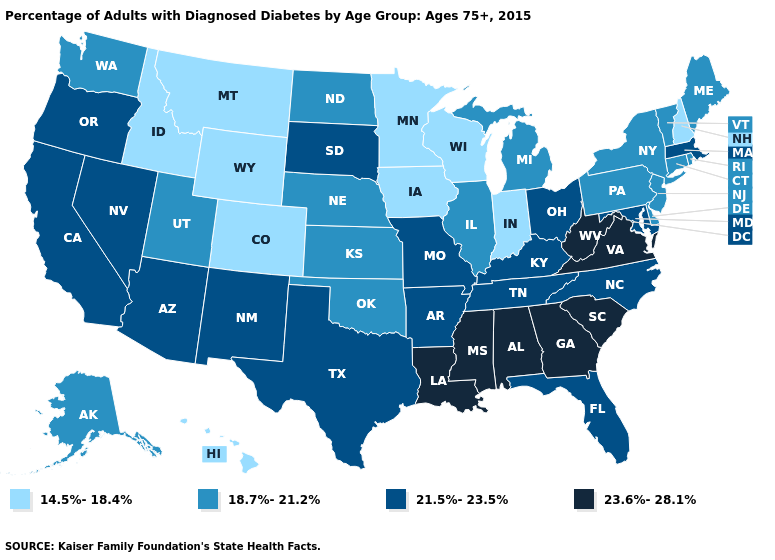Among the states that border North Dakota , which have the highest value?
Concise answer only. South Dakota. Is the legend a continuous bar?
Keep it brief. No. Does South Carolina have the lowest value in the USA?
Short answer required. No. Does Delaware have the same value as Indiana?
Be succinct. No. Among the states that border Delaware , does Maryland have the lowest value?
Keep it brief. No. What is the value of North Dakota?
Give a very brief answer. 18.7%-21.2%. What is the value of Massachusetts?
Concise answer only. 21.5%-23.5%. Among the states that border Rhode Island , does Connecticut have the lowest value?
Be succinct. Yes. Does Mississippi have a higher value than California?
Be succinct. Yes. How many symbols are there in the legend?
Short answer required. 4. Does Wyoming have the same value as New Mexico?
Keep it brief. No. Which states hav the highest value in the West?
Quick response, please. Arizona, California, Nevada, New Mexico, Oregon. Name the states that have a value in the range 18.7%-21.2%?
Write a very short answer. Alaska, Connecticut, Delaware, Illinois, Kansas, Maine, Michigan, Nebraska, New Jersey, New York, North Dakota, Oklahoma, Pennsylvania, Rhode Island, Utah, Vermont, Washington. Name the states that have a value in the range 21.5%-23.5%?
Be succinct. Arizona, Arkansas, California, Florida, Kentucky, Maryland, Massachusetts, Missouri, Nevada, New Mexico, North Carolina, Ohio, Oregon, South Dakota, Tennessee, Texas. Name the states that have a value in the range 14.5%-18.4%?
Short answer required. Colorado, Hawaii, Idaho, Indiana, Iowa, Minnesota, Montana, New Hampshire, Wisconsin, Wyoming. 